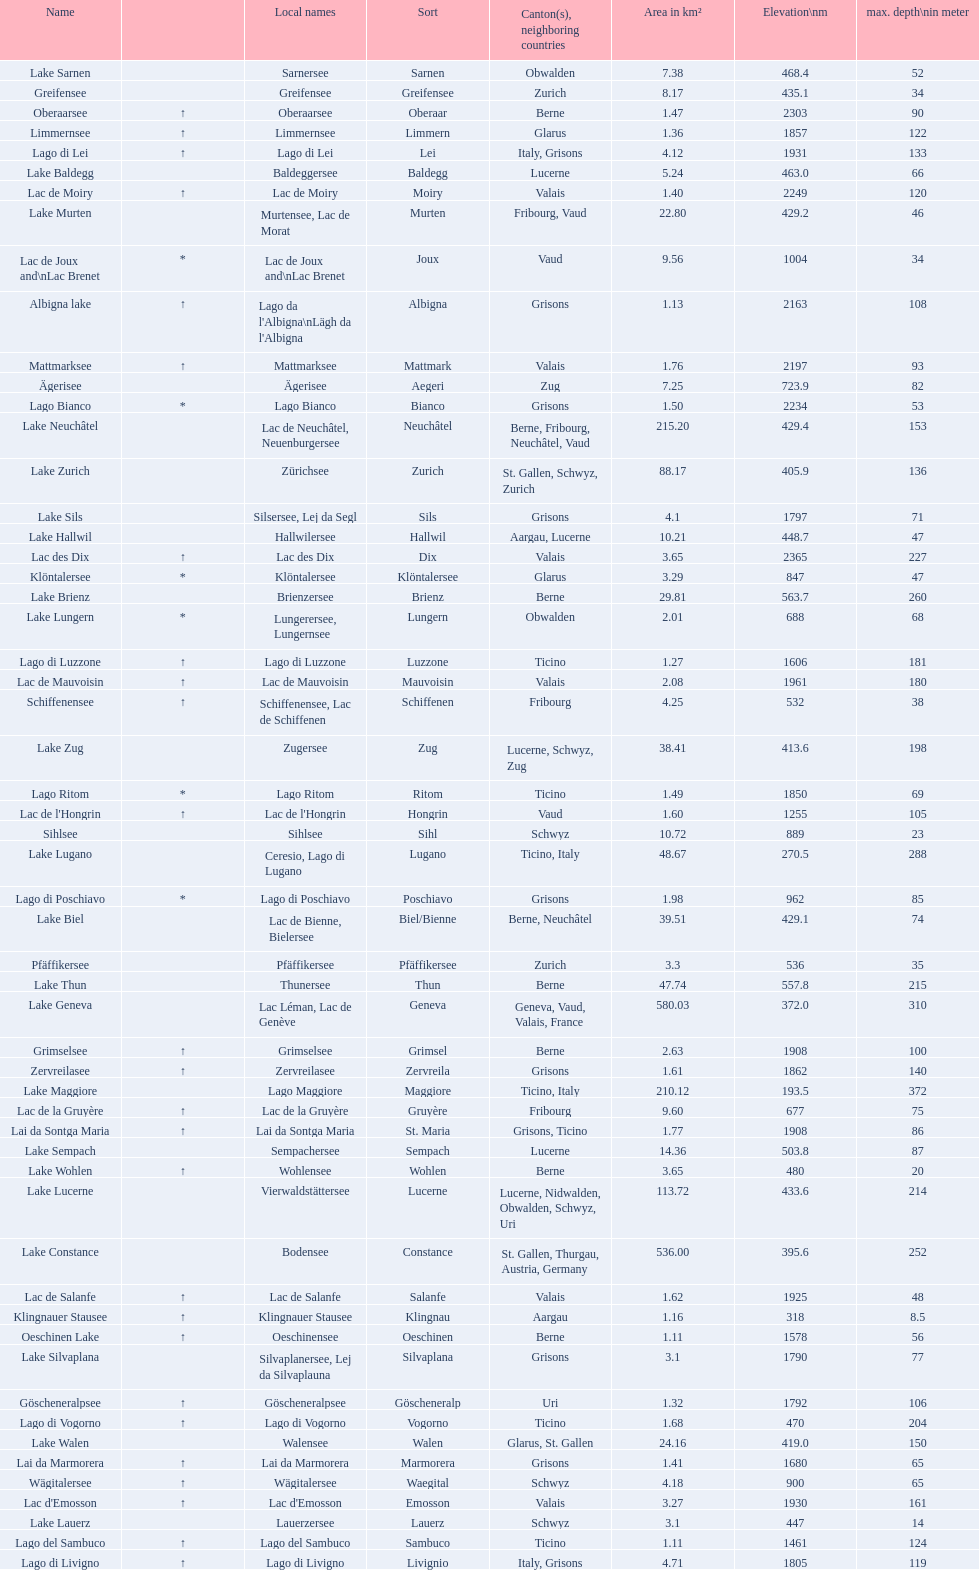Name the largest lake Lake Geneva. 